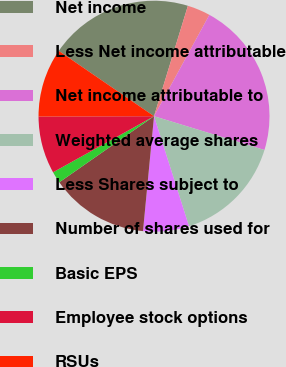<chart> <loc_0><loc_0><loc_500><loc_500><pie_chart><fcel>Net income<fcel>Less Net income attributable<fcel>Net income attributable to<fcel>Weighted average shares<fcel>Less Shares subject to<fcel>Number of shares used for<fcel>Basic EPS<fcel>Employee stock options<fcel>RSUs<nl><fcel>20.17%<fcel>3.22%<fcel>21.77%<fcel>15.38%<fcel>6.42%<fcel>13.78%<fcel>1.63%<fcel>8.02%<fcel>9.62%<nl></chart> 